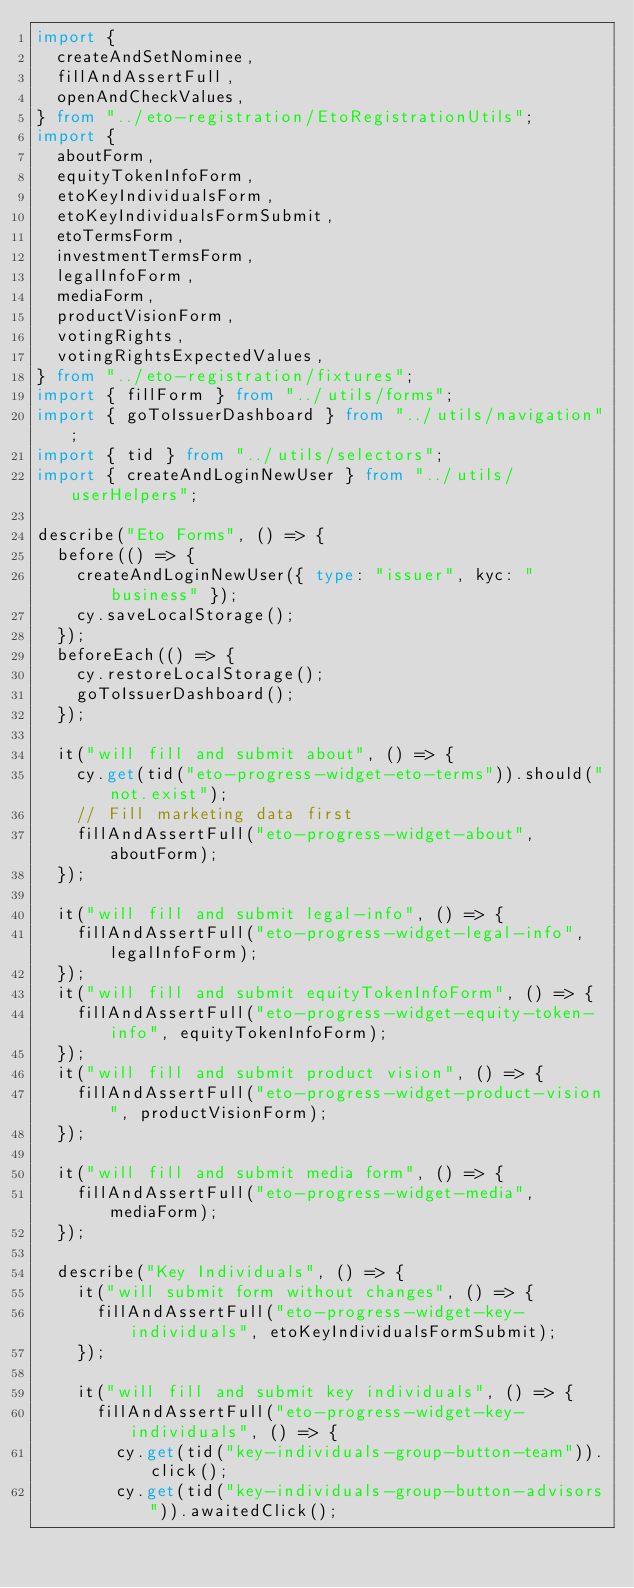<code> <loc_0><loc_0><loc_500><loc_500><_TypeScript_>import {
  createAndSetNominee,
  fillAndAssertFull,
  openAndCheckValues,
} from "../eto-registration/EtoRegistrationUtils";
import {
  aboutForm,
  equityTokenInfoForm,
  etoKeyIndividualsForm,
  etoKeyIndividualsFormSubmit,
  etoTermsForm,
  investmentTermsForm,
  legalInfoForm,
  mediaForm,
  productVisionForm,
  votingRights,
  votingRightsExpectedValues,
} from "../eto-registration/fixtures";
import { fillForm } from "../utils/forms";
import { goToIssuerDashboard } from "../utils/navigation";
import { tid } from "../utils/selectors";
import { createAndLoginNewUser } from "../utils/userHelpers";

describe("Eto Forms", () => {
  before(() => {
    createAndLoginNewUser({ type: "issuer", kyc: "business" });
    cy.saveLocalStorage();
  });
  beforeEach(() => {
    cy.restoreLocalStorage();
    goToIssuerDashboard();
  });

  it("will fill and submit about", () => {
    cy.get(tid("eto-progress-widget-eto-terms")).should("not.exist");
    // Fill marketing data first
    fillAndAssertFull("eto-progress-widget-about", aboutForm);
  });

  it("will fill and submit legal-info", () => {
    fillAndAssertFull("eto-progress-widget-legal-info", legalInfoForm);
  });
  it("will fill and submit equityTokenInfoForm", () => {
    fillAndAssertFull("eto-progress-widget-equity-token-info", equityTokenInfoForm);
  });
  it("will fill and submit product vision", () => {
    fillAndAssertFull("eto-progress-widget-product-vision", productVisionForm);
  });

  it("will fill and submit media form", () => {
    fillAndAssertFull("eto-progress-widget-media", mediaForm);
  });

  describe("Key Individuals", () => {
    it("will submit form without changes", () => {
      fillAndAssertFull("eto-progress-widget-key-individuals", etoKeyIndividualsFormSubmit);
    });

    it("will fill and submit key individuals", () => {
      fillAndAssertFull("eto-progress-widget-key-individuals", () => {
        cy.get(tid("key-individuals-group-button-team")).click();
        cy.get(tid("key-individuals-group-button-advisors")).awaitedClick();</code> 